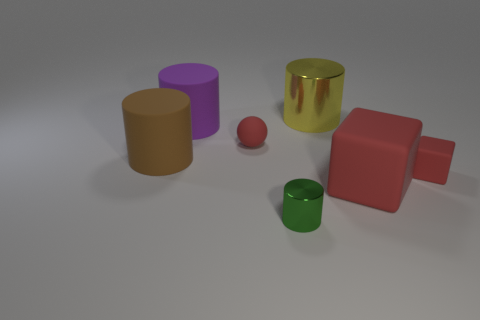Are there any other things that are the same color as the small block?
Your answer should be very brief. Yes. Do the big matte object right of the purple rubber cylinder and the tiny matte thing on the right side of the sphere have the same color?
Keep it short and to the point. Yes. The large matte thing that is the same color as the small sphere is what shape?
Offer a very short reply. Cube. There is another rubber cylinder that is the same size as the brown cylinder; what is its color?
Your response must be concise. Purple. What number of metallic objects are tiny red balls or green cylinders?
Keep it short and to the point. 1. How many objects are behind the tiny red rubber ball and to the left of the yellow cylinder?
Provide a short and direct response. 1. Are there any other things that have the same shape as the big yellow metallic object?
Provide a succinct answer. Yes. What number of other things are there of the same size as the brown matte cylinder?
Make the answer very short. 3. There is a cylinder that is behind the purple cylinder; is it the same size as the metal object that is in front of the purple rubber object?
Your answer should be very brief. No. What number of things are either big brown matte objects or metal cylinders to the right of the large brown matte cylinder?
Offer a very short reply. 3. 